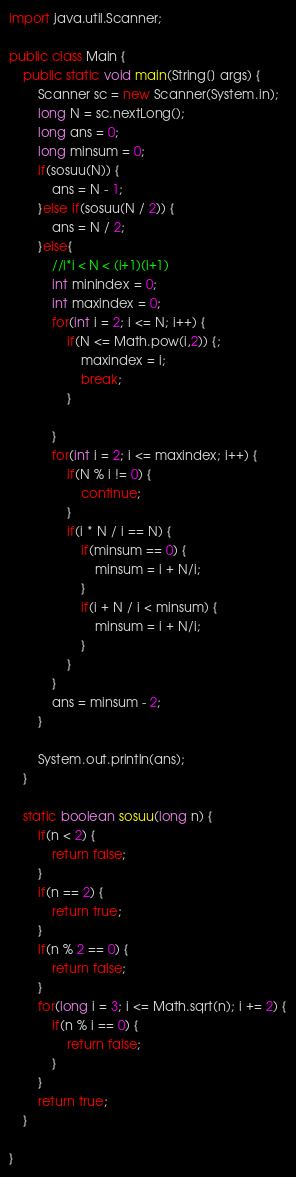<code> <loc_0><loc_0><loc_500><loc_500><_Java_>import java.util.Scanner;
 
public class Main {
	public static void main(String[] args) {
	    Scanner sc = new Scanner(System.in);
	    long N = sc.nextLong();
	    long ans = 0;
	    long minsum = 0;
	    if(sosuu(N)) {
	        ans = N - 1;
	    }else if(sosuu(N / 2)) {
            ans = N / 2; 
        }else{
            //i*i < N < (i+1)(i+1)
            int minindex = 0;
            int maxindex = 0;
            for(int i = 2; i <= N; i++) {
                if(N <= Math.pow(i,2)) {;
                    maxindex = i;
                    break;
                }
                
            }
	        for(int i = 2; i <= maxindex; i++) {
	            if(N % i != 0) {
	                continue;
	            }
                if(i * N / i == N) {
                    if(minsum == 0) {
                        minsum = i + N/i;
                    }
                    if(i + N / i < minsum) {
                        minsum = i + N/i;
                    }
                }
	        }
	        ans = minsum - 2;
	    }
        
        System.out.println(ans);
	}
	
	static boolean sosuu(long n) {
	    if(n < 2) {
	        return false;
	    }
	    if(n == 2) {
	        return true;
	    }
	    if(n % 2 == 0) {
	        return false;
	    }
	    for(long i = 3; i <= Math.sqrt(n); i += 2) {
	        if(n % i == 0) {
	            return false;
	        }
	    }
	    return true;
	}

}</code> 